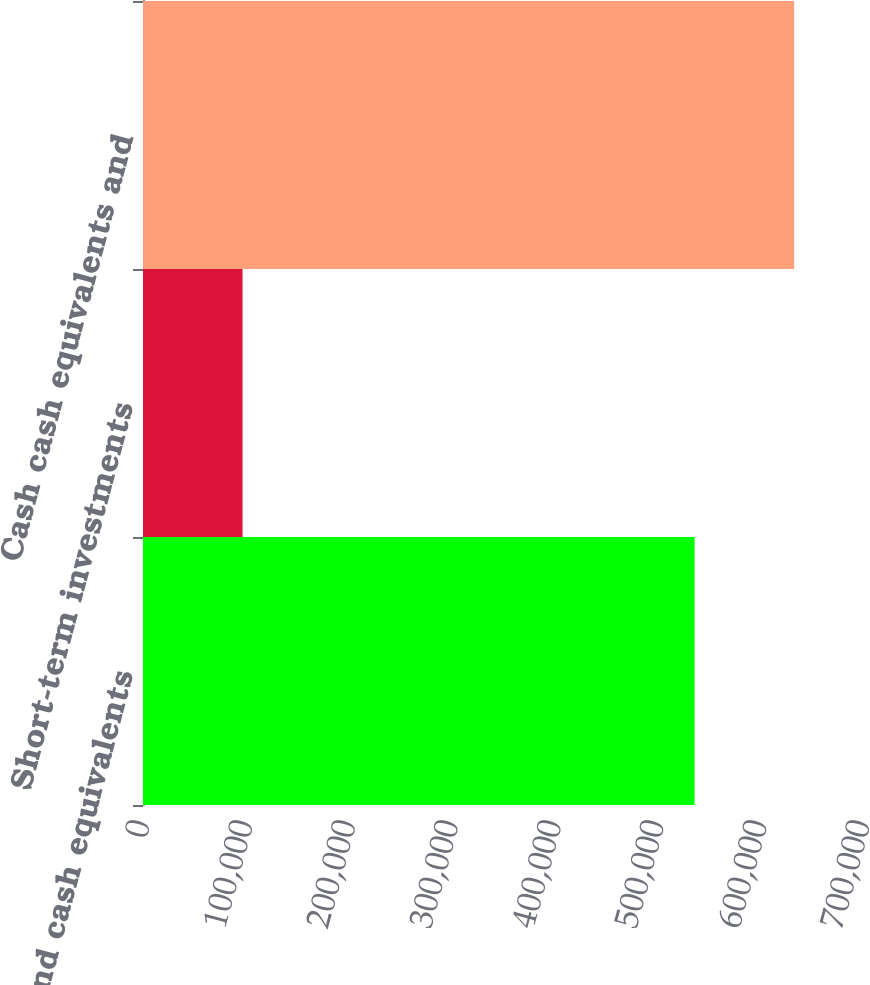Convert chart to OTSL. <chart><loc_0><loc_0><loc_500><loc_500><bar_chart><fcel>Cash and cash equivalents<fcel>Short-term investments<fcel>Cash cash equivalents and<nl><fcel>536260<fcel>96788<fcel>633048<nl></chart> 